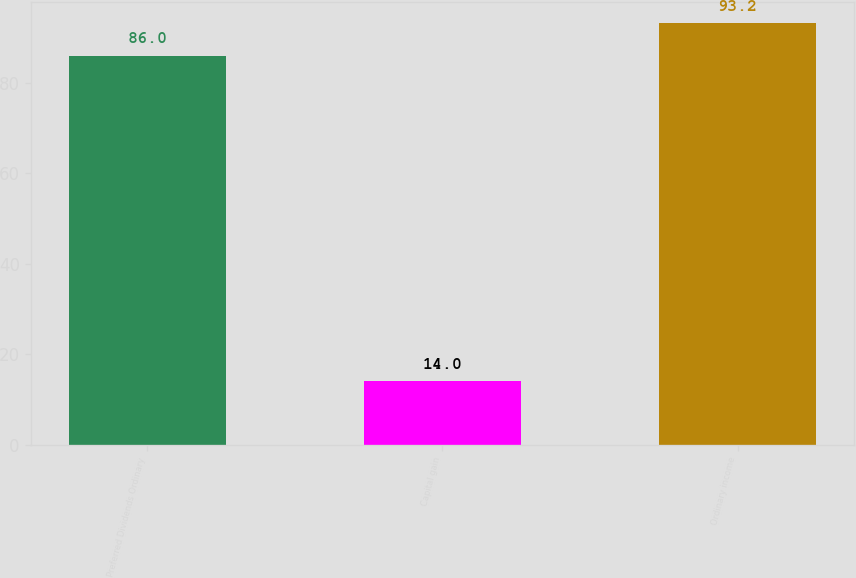Convert chart to OTSL. <chart><loc_0><loc_0><loc_500><loc_500><bar_chart><fcel>Preferred Dividends Ordinary<fcel>Capital gain<fcel>Ordinary income<nl><fcel>86<fcel>14<fcel>93.2<nl></chart> 